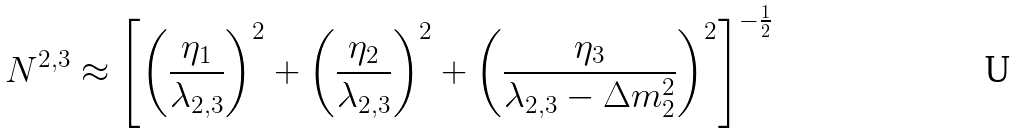<formula> <loc_0><loc_0><loc_500><loc_500>N ^ { 2 , 3 } \approx \left [ \left ( \frac { \eta _ { 1 } } { \lambda _ { 2 , 3 } } \right ) ^ { 2 } + \left ( \frac { \eta _ { 2 } } { \lambda _ { 2 , 3 } } \right ) ^ { 2 } + \left ( \frac { \eta _ { 3 } } { \lambda _ { 2 , 3 } - \Delta m _ { 2 } ^ { 2 } } \right ) ^ { 2 } \right ] ^ { - \frac { 1 } { 2 } }</formula> 